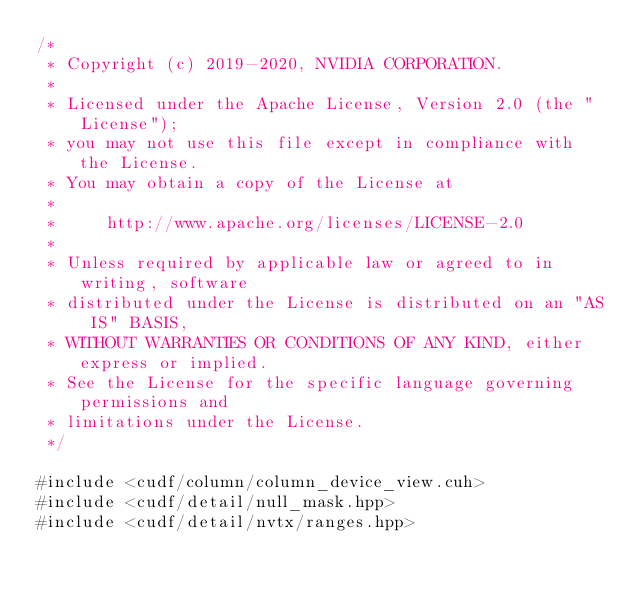<code> <loc_0><loc_0><loc_500><loc_500><_Cuda_>/*
 * Copyright (c) 2019-2020, NVIDIA CORPORATION.
 *
 * Licensed under the Apache License, Version 2.0 (the "License");
 * you may not use this file except in compliance with the License.
 * You may obtain a copy of the License at
 *
 *     http://www.apache.org/licenses/LICENSE-2.0
 *
 * Unless required by applicable law or agreed to in writing, software
 * distributed under the License is distributed on an "AS IS" BASIS,
 * WITHOUT WARRANTIES OR CONDITIONS OF ANY KIND, either express or implied.
 * See the License for the specific language governing permissions and
 * limitations under the License.
 */

#include <cudf/column/column_device_view.cuh>
#include <cudf/detail/null_mask.hpp>
#include <cudf/detail/nvtx/ranges.hpp></code> 